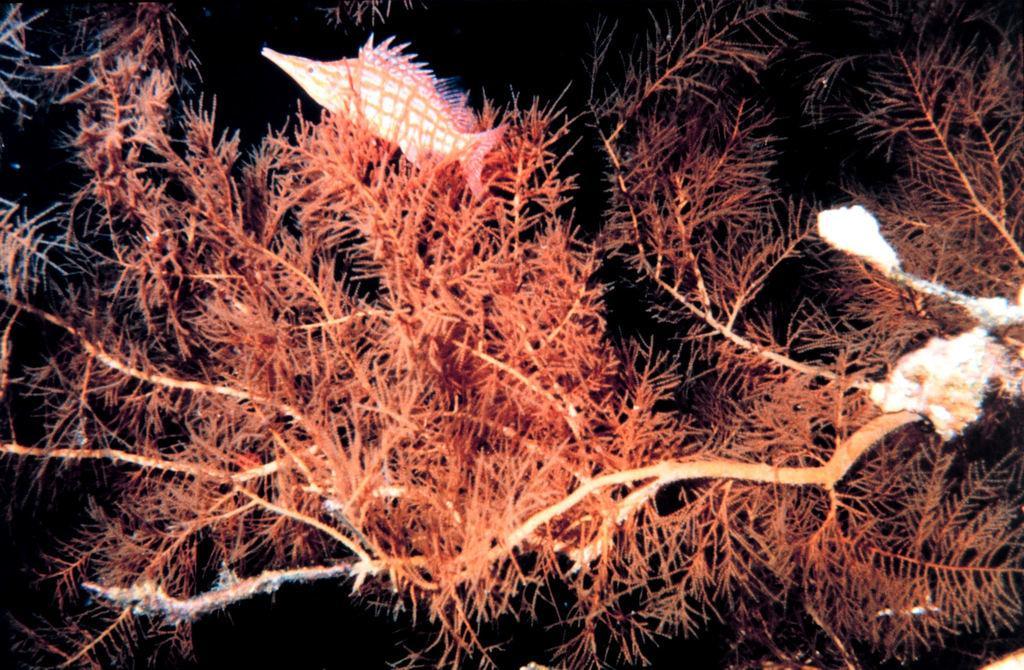Could you give a brief overview of what you see in this image? In this image there is a fish at the top. At the bottom there are plants which are in red colour. 